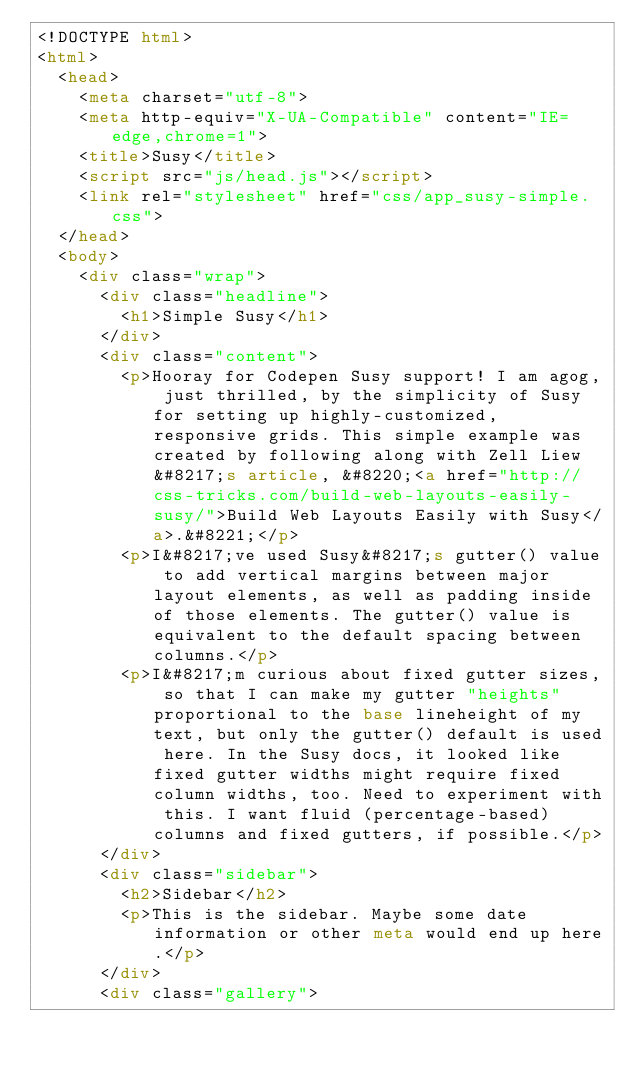Convert code to text. <code><loc_0><loc_0><loc_500><loc_500><_HTML_><!DOCTYPE html>
<html>
  <head>
    <meta charset="utf-8">
    <meta http-equiv="X-UA-Compatible" content="IE=edge,chrome=1">
    <title>Susy</title>
    <script src="js/head.js"></script>
    <link rel="stylesheet" href="css/app_susy-simple.css">
  </head>
  <body>
    <div class="wrap">
      <div class="headline">
        <h1>Simple Susy</h1>
      </div>
      <div class="content">
        <p>Hooray for Codepen Susy support! I am agog, just thrilled, by the simplicity of Susy for setting up highly-customized, responsive grids. This simple example was created by following along with Zell Liew&#8217;s article, &#8220;<a href="http://css-tricks.com/build-web-layouts-easily-susy/">Build Web Layouts Easily with Susy</a>.&#8221;</p>
        <p>I&#8217;ve used Susy&#8217;s gutter() value to add vertical margins between major layout elements, as well as padding inside of those elements. The gutter() value is equivalent to the default spacing between columns.</p>
        <p>I&#8217;m curious about fixed gutter sizes, so that I can make my gutter "heights" proportional to the base lineheight of my text, but only the gutter() default is used here. In the Susy docs, it looked like fixed gutter widths might require fixed column widths, too. Need to experiment with this. I want fluid (percentage-based) columns and fixed gutters, if possible.</p>
      </div>
      <div class="sidebar">
        <h2>Sidebar</h2>
        <p>This is the sidebar. Maybe some date information or other meta would end up here.</p>
      </div>
      <div class="gallery"></code> 